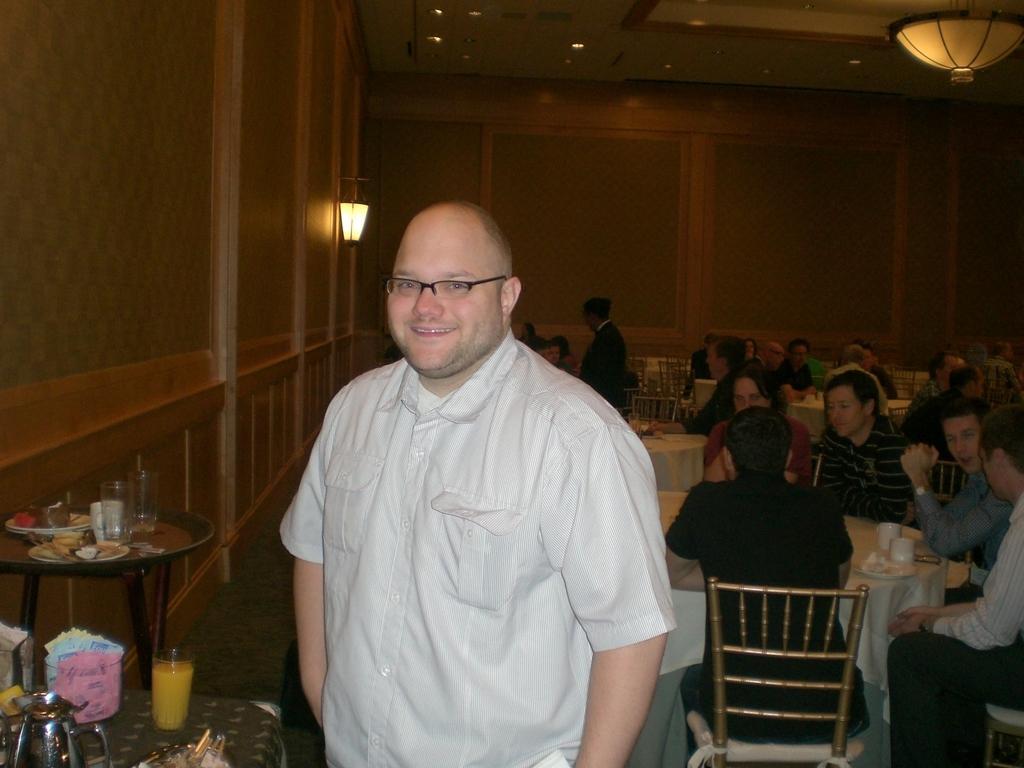Please provide a concise description of this image. This picture shows and inside view of restaurant. There are many people sitting on chairs at the tables. On the table at the left corner of the image there are glasses, plates, food, mugs and juices. There is a man standing in the center wearing a white shirt and spectacles. He is smiling. There is a wall lamp to the wall. There are lights to the ceiling. The wall is furnished with wood. 